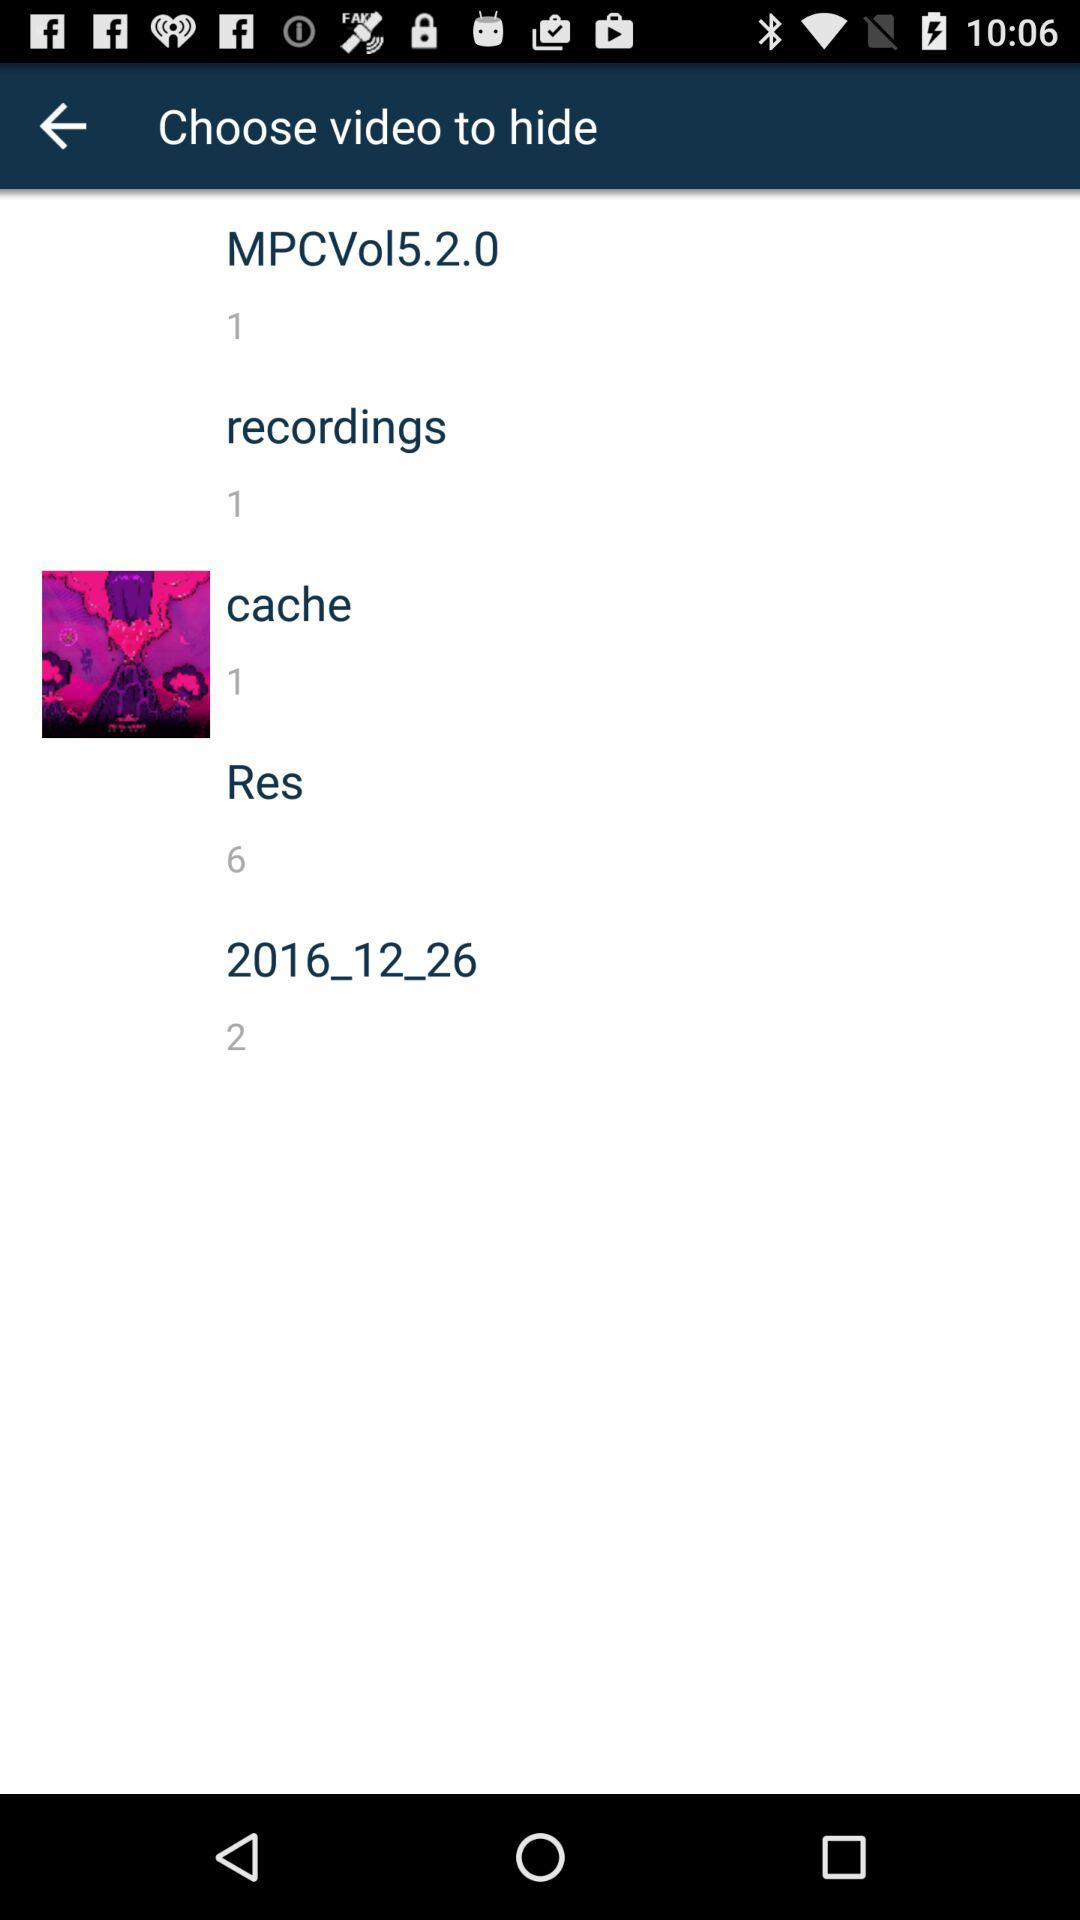How many videos are in "recordings"? There is 1 video in "recordings". 